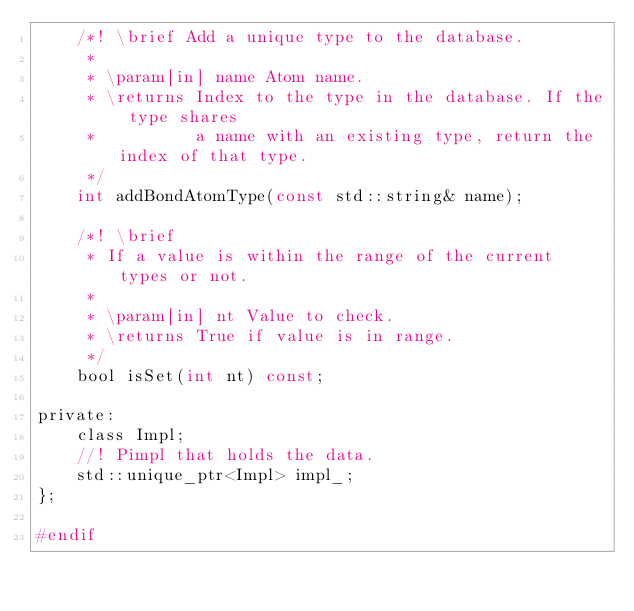Convert code to text. <code><loc_0><loc_0><loc_500><loc_500><_C_>    /*! \brief Add a unique type to the database.
     *
     * \param[in] name Atom name.
     * \returns Index to the type in the database. If the type shares
     *          a name with an existing type, return the index of that type.
     */
    int addBondAtomType(const std::string& name);

    /*! \brief
     * If a value is within the range of the current types or not.
     *
     * \param[in] nt Value to check.
     * \returns True if value is in range.
     */
    bool isSet(int nt) const;

private:
    class Impl;
    //! Pimpl that holds the data.
    std::unique_ptr<Impl> impl_;
};

#endif
</code> 